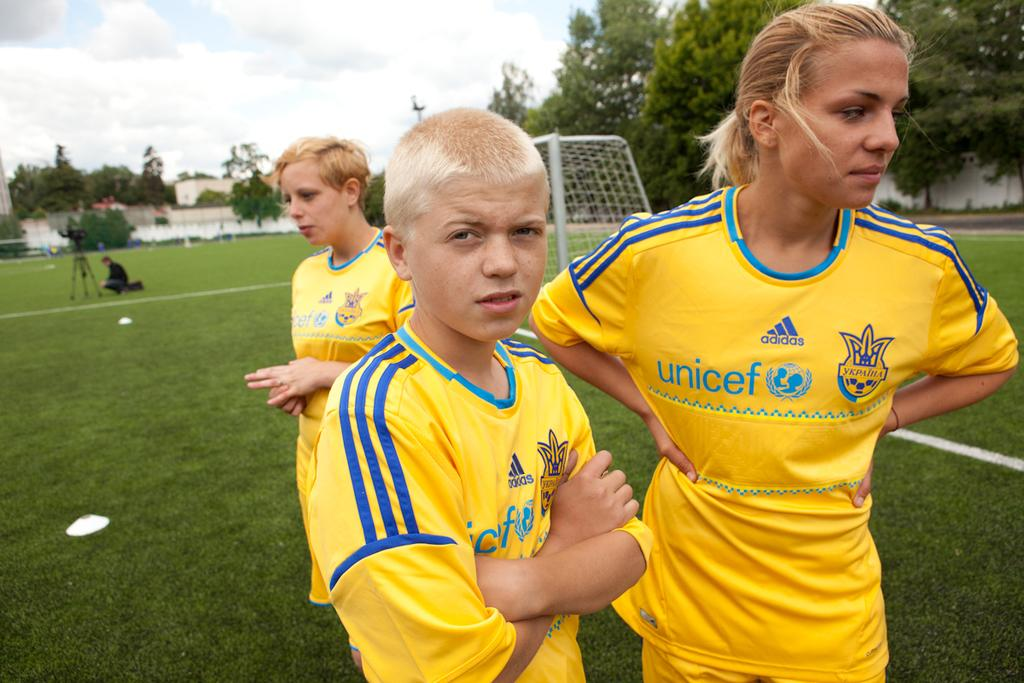<image>
Provide a brief description of the given image. a jersey with the word Unicef on it 